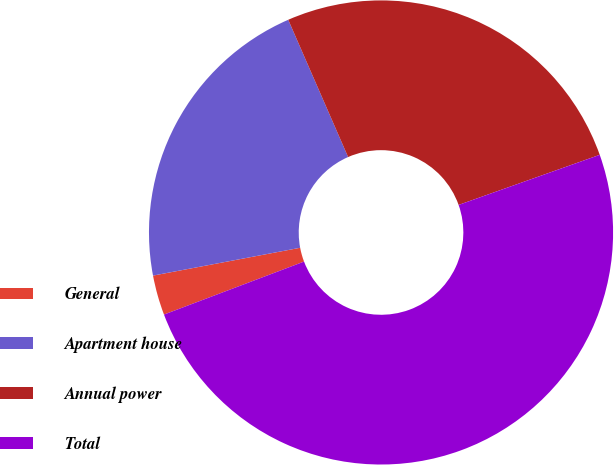Convert chart to OTSL. <chart><loc_0><loc_0><loc_500><loc_500><pie_chart><fcel>General<fcel>Apartment house<fcel>Annual power<fcel>Total<nl><fcel>2.78%<fcel>21.43%<fcel>26.12%<fcel>49.68%<nl></chart> 